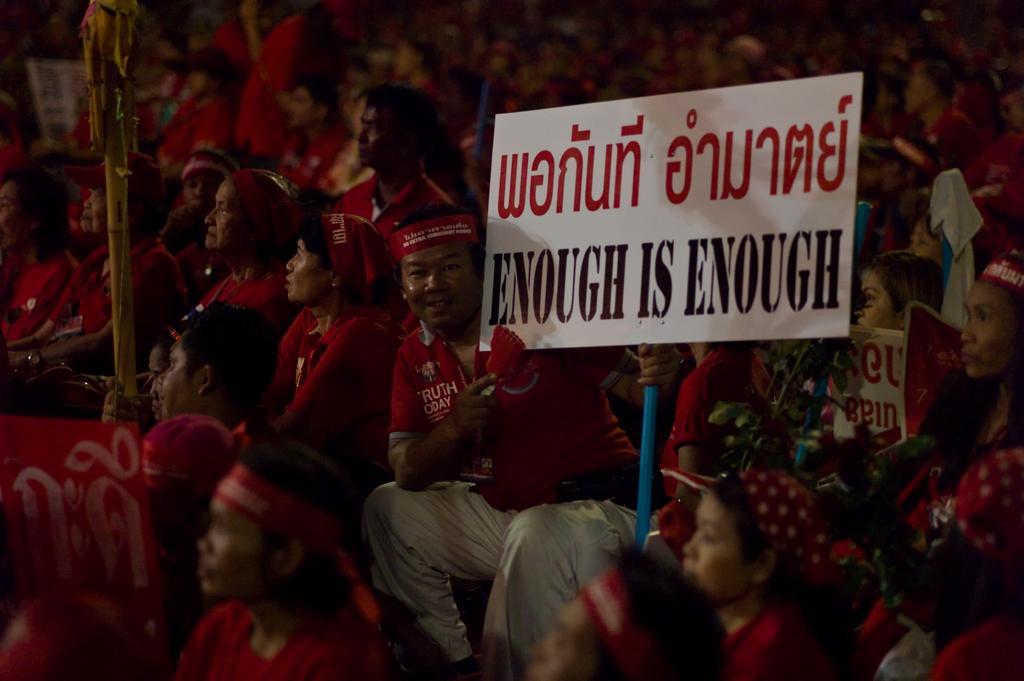Please provide a concise description of this image. In the image there is a crowd and most of them are wearing red dress and few people were holding some boards in their hands. 